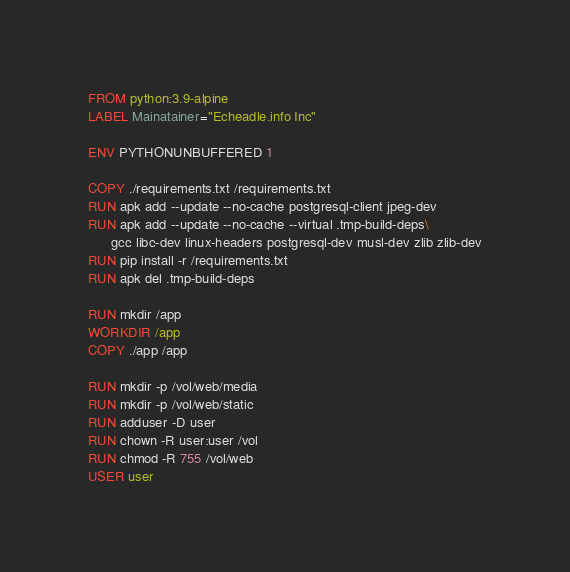Convert code to text. <code><loc_0><loc_0><loc_500><loc_500><_Dockerfile_>FROM python:3.9-alpine
LABEL Mainatainer="Echeadle.info Inc"

ENV PYTHONUNBUFFERED 1

COPY ./requirements.txt /requirements.txt
RUN apk add --update --no-cache postgresql-client jpeg-dev
RUN apk add --update --no-cache --virtual .tmp-build-deps\
      gcc libc-dev linux-headers postgresql-dev musl-dev zlib zlib-dev
RUN pip install -r /requirements.txt
RUN apk del .tmp-build-deps

RUN mkdir /app
WORKDIR /app
COPY ./app /app

RUN mkdir -p /vol/web/media
RUN mkdir -p /vol/web/static
RUN adduser -D user
RUN chown -R user:user /vol
RUN chmod -R 755 /vol/web
USER user
</code> 